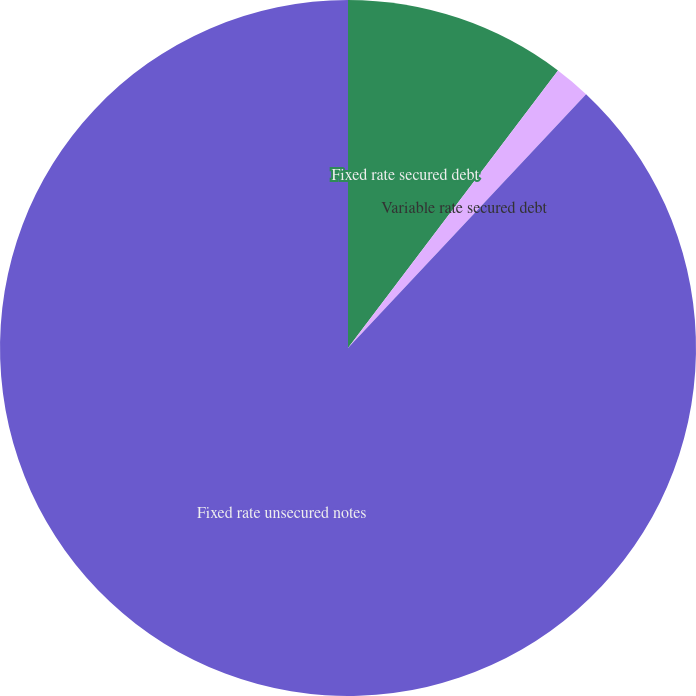<chart> <loc_0><loc_0><loc_500><loc_500><pie_chart><fcel>Fixed rate secured debt<fcel>Variable rate secured debt<fcel>Fixed rate unsecured notes<nl><fcel>10.31%<fcel>1.68%<fcel>88.0%<nl></chart> 